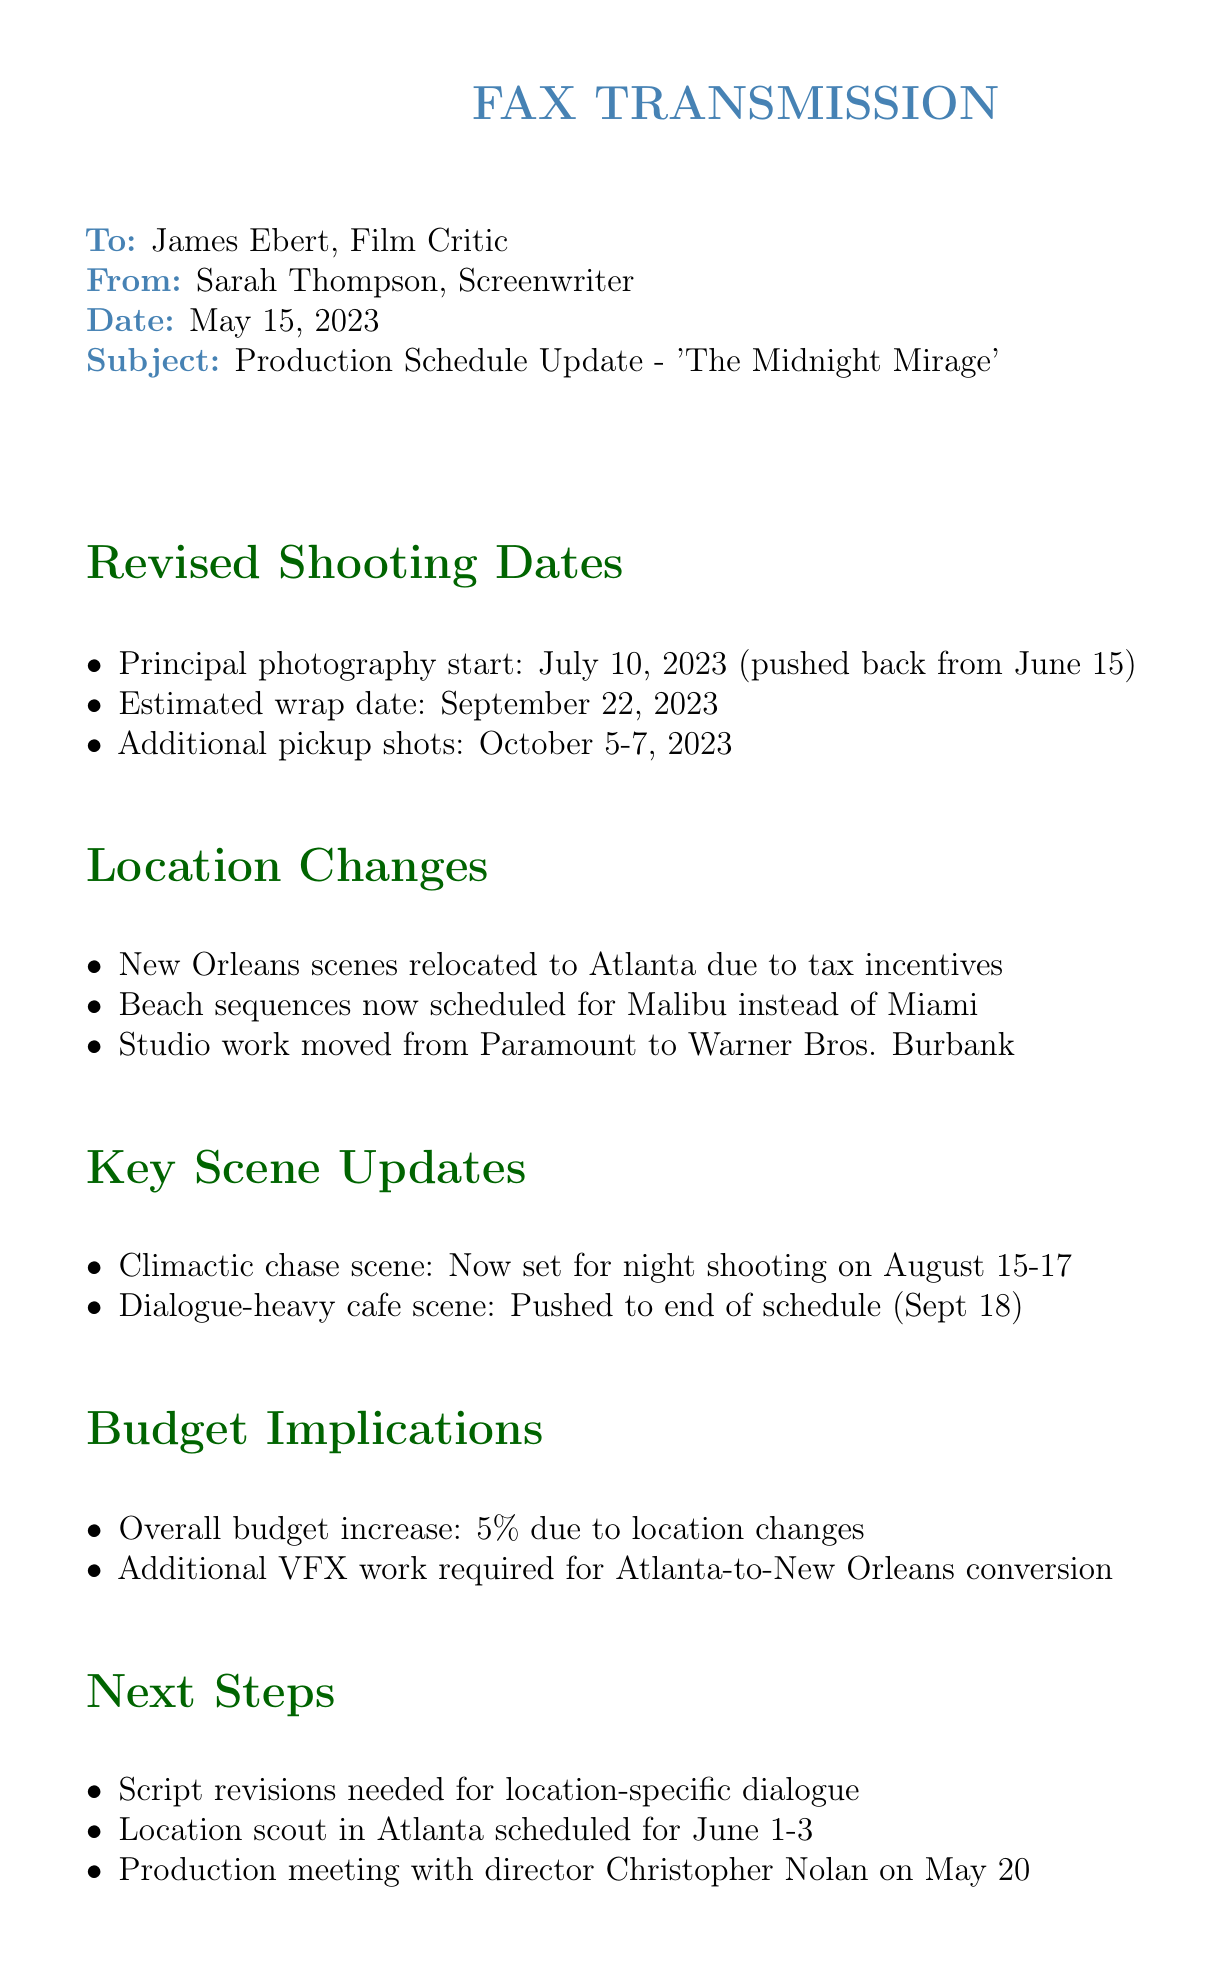What is the new principal photography start date? The document states that the principal photography starts on July 10, 2023, which was pushed back from June 15.
Answer: July 10, 2023 Where have the New Orleans scenes been relocated? The document mentions that the New Orleans scenes have been relocated to Atlanta due to tax incentives.
Answer: Atlanta What is the overall budget increase percentage? The document indicates that the overall budget increase is 5% due to location changes.
Answer: 5% When is the production meeting scheduled with the director? According to the document, the production meeting with director Christopher Nolan is scheduled for May 20.
Answer: May 20 What are the revised dates for the additional pickup shots? The document specifies that the additional pickup shots are scheduled for October 5-7, 2023.
Answer: October 5-7, 2023 Which location is mentioned for the beach sequences? The document states that the beach sequences are now scheduled for Malibu instead of Miami.
Answer: Malibu What is required for the Atlanta-to-New Orleans conversion? The document notes that additional VFX work is required for the Atlanta-to-New Orleans conversion.
Answer: Additional VFX work What is the key scene that is set for night shooting? The document highlights that the climactic chase scene is now set for night shooting on August 15-17.
Answer: Climactic chase scene What is the deadline for feedback on the changes? The document mentions that feedback on the changes is needed by May 18.
Answer: May 18 